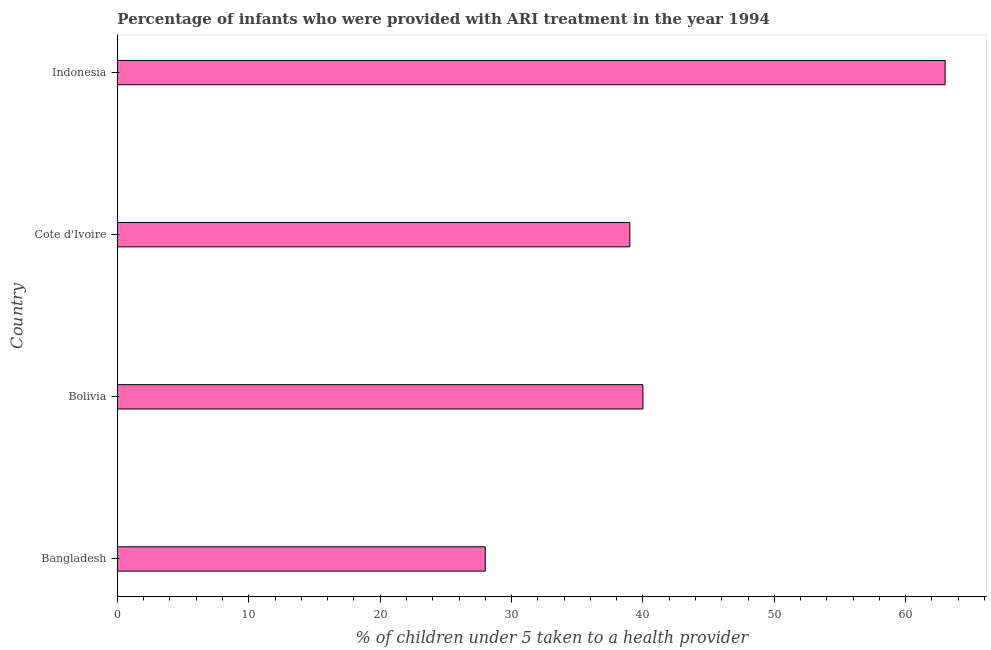Does the graph contain any zero values?
Make the answer very short. No. Does the graph contain grids?
Provide a short and direct response. No. What is the title of the graph?
Provide a succinct answer. Percentage of infants who were provided with ARI treatment in the year 1994. What is the label or title of the X-axis?
Make the answer very short. % of children under 5 taken to a health provider. What is the percentage of children who were provided with ari treatment in Indonesia?
Provide a succinct answer. 63. Across all countries, what is the maximum percentage of children who were provided with ari treatment?
Keep it short and to the point. 63. Across all countries, what is the minimum percentage of children who were provided with ari treatment?
Your answer should be very brief. 28. What is the sum of the percentage of children who were provided with ari treatment?
Your response must be concise. 170. What is the difference between the percentage of children who were provided with ari treatment in Bangladesh and Bolivia?
Give a very brief answer. -12. What is the median percentage of children who were provided with ari treatment?
Make the answer very short. 39.5. In how many countries, is the percentage of children who were provided with ari treatment greater than 16 %?
Provide a short and direct response. 4. Is the sum of the percentage of children who were provided with ari treatment in Bangladesh and Indonesia greater than the maximum percentage of children who were provided with ari treatment across all countries?
Offer a very short reply. Yes. What is the difference between the highest and the lowest percentage of children who were provided with ari treatment?
Ensure brevity in your answer.  35. In how many countries, is the percentage of children who were provided with ari treatment greater than the average percentage of children who were provided with ari treatment taken over all countries?
Keep it short and to the point. 1. How many bars are there?
Your response must be concise. 4. Are all the bars in the graph horizontal?
Offer a very short reply. Yes. How many countries are there in the graph?
Offer a very short reply. 4. What is the difference between two consecutive major ticks on the X-axis?
Make the answer very short. 10. Are the values on the major ticks of X-axis written in scientific E-notation?
Offer a very short reply. No. What is the % of children under 5 taken to a health provider in Indonesia?
Give a very brief answer. 63. What is the difference between the % of children under 5 taken to a health provider in Bangladesh and Bolivia?
Your response must be concise. -12. What is the difference between the % of children under 5 taken to a health provider in Bangladesh and Indonesia?
Provide a succinct answer. -35. What is the difference between the % of children under 5 taken to a health provider in Bolivia and Indonesia?
Offer a very short reply. -23. What is the difference between the % of children under 5 taken to a health provider in Cote d'Ivoire and Indonesia?
Provide a short and direct response. -24. What is the ratio of the % of children under 5 taken to a health provider in Bangladesh to that in Bolivia?
Your answer should be compact. 0.7. What is the ratio of the % of children under 5 taken to a health provider in Bangladesh to that in Cote d'Ivoire?
Keep it short and to the point. 0.72. What is the ratio of the % of children under 5 taken to a health provider in Bangladesh to that in Indonesia?
Ensure brevity in your answer.  0.44. What is the ratio of the % of children under 5 taken to a health provider in Bolivia to that in Indonesia?
Your response must be concise. 0.64. What is the ratio of the % of children under 5 taken to a health provider in Cote d'Ivoire to that in Indonesia?
Your answer should be very brief. 0.62. 